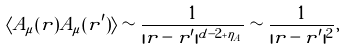Convert formula to latex. <formula><loc_0><loc_0><loc_500><loc_500>\langle A _ { \mu } ( { r } ) A _ { \mu } ( { r } ^ { \prime } ) \rangle \sim \frac { 1 } { | { r } - { r } ^ { \prime } | ^ { d - 2 + \eta _ { A } } } \sim \frac { 1 } { | { r } - { r } ^ { \prime } | ^ { 2 } } ,</formula> 